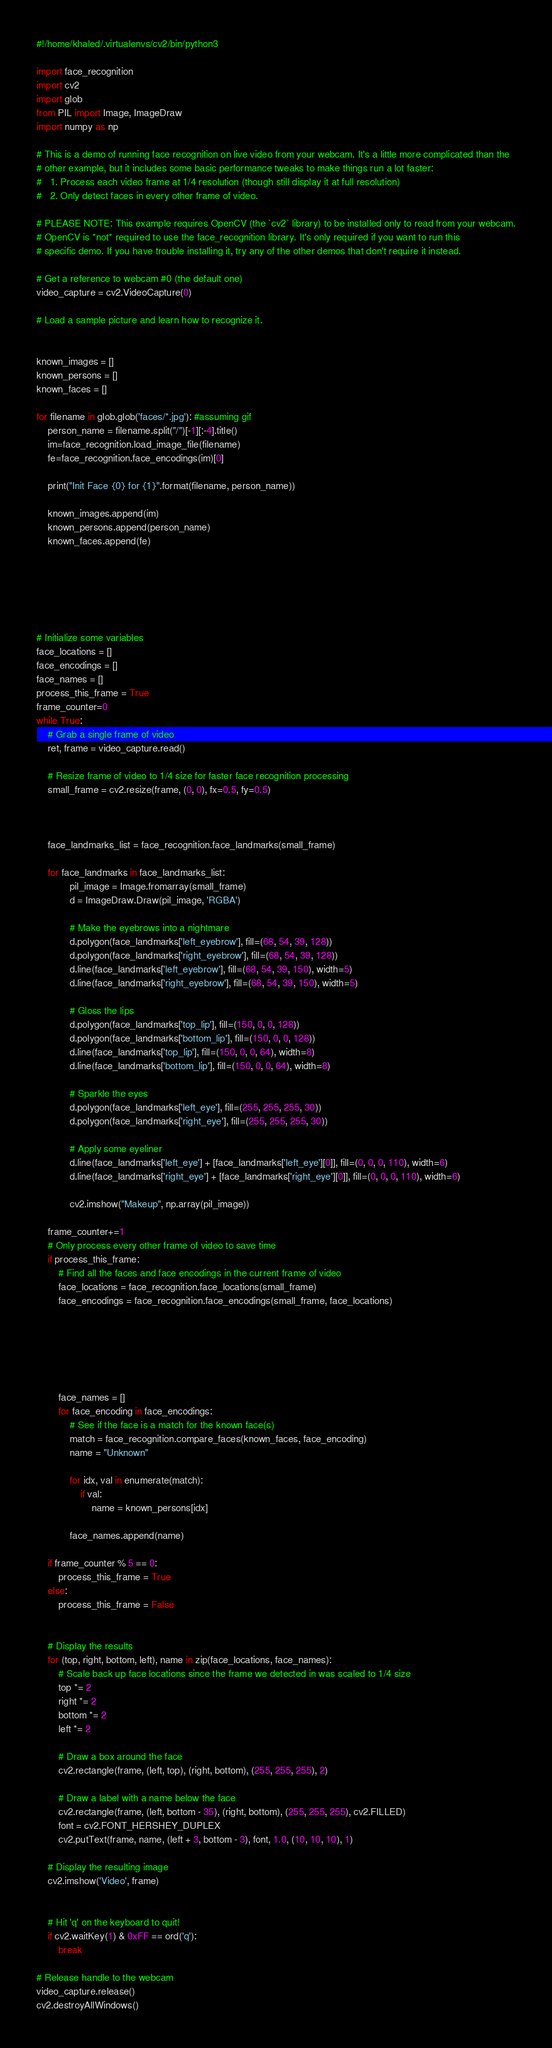<code> <loc_0><loc_0><loc_500><loc_500><_Python_>#!/home/khaled/.virtualenvs/cv2/bin/python3

import face_recognition
import cv2
import glob
from PIL import Image, ImageDraw
import numpy as np

# This is a demo of running face recognition on live video from your webcam. It's a little more complicated than the
# other example, but it includes some basic performance tweaks to make things run a lot faster:
#   1. Process each video frame at 1/4 resolution (though still display it at full resolution)
#   2. Only detect faces in every other frame of video.

# PLEASE NOTE: This example requires OpenCV (the `cv2` library) to be installed only to read from your webcam.
# OpenCV is *not* required to use the face_recognition library. It's only required if you want to run this
# specific demo. If you have trouble installing it, try any of the other demos that don't require it instead.

# Get a reference to webcam #0 (the default one)
video_capture = cv2.VideoCapture(0)

# Load a sample picture and learn how to recognize it.


known_images = []
known_persons = []
known_faces = []

for filename in glob.glob('faces/*.jpg'): #assuming gif
    person_name = filename.split("/")[-1][:-4].title()
    im=face_recognition.load_image_file(filename)
    fe=face_recognition.face_encodings(im)[0]

    print("Init Face {0} for {1}".format(filename, person_name))

    known_images.append(im)
    known_persons.append(person_name)
    known_faces.append(fe)






# Initialize some variables
face_locations = []
face_encodings = []
face_names = []
process_this_frame = True
frame_counter=0
while True:
    # Grab a single frame of video
    ret, frame = video_capture.read()

    # Resize frame of video to 1/4 size for faster face recognition processing
    small_frame = cv2.resize(frame, (0, 0), fx=0.5, fy=0.5)



    face_landmarks_list = face_recognition.face_landmarks(small_frame)
        
    for face_landmarks in face_landmarks_list:
            pil_image = Image.fromarray(small_frame)
            d = ImageDraw.Draw(pil_image, 'RGBA')

            # Make the eyebrows into a nightmare
            d.polygon(face_landmarks['left_eyebrow'], fill=(68, 54, 39, 128))
            d.polygon(face_landmarks['right_eyebrow'], fill=(68, 54, 39, 128))
            d.line(face_landmarks['left_eyebrow'], fill=(68, 54, 39, 150), width=5)
            d.line(face_landmarks['right_eyebrow'], fill=(68, 54, 39, 150), width=5)

            # Gloss the lips
            d.polygon(face_landmarks['top_lip'], fill=(150, 0, 0, 128))
            d.polygon(face_landmarks['bottom_lip'], fill=(150, 0, 0, 128))
            d.line(face_landmarks['top_lip'], fill=(150, 0, 0, 64), width=8)
            d.line(face_landmarks['bottom_lip'], fill=(150, 0, 0, 64), width=8)

            # Sparkle the eyes
            d.polygon(face_landmarks['left_eye'], fill=(255, 255, 255, 30))
            d.polygon(face_landmarks['right_eye'], fill=(255, 255, 255, 30))

            # Apply some eyeliner
            d.line(face_landmarks['left_eye'] + [face_landmarks['left_eye'][0]], fill=(0, 0, 0, 110), width=6)
            d.line(face_landmarks['right_eye'] + [face_landmarks['right_eye'][0]], fill=(0, 0, 0, 110), width=6)

            cv2.imshow("Makeup", np.array(pil_image))

    frame_counter+=1
    # Only process every other frame of video to save time
    if process_this_frame:
        # Find all the faces and face encodings in the current frame of video
        face_locations = face_recognition.face_locations(small_frame)
        face_encodings = face_recognition.face_encodings(small_frame, face_locations)

            




        face_names = []
        for face_encoding in face_encodings:
            # See if the face is a match for the known face(s)
            match = face_recognition.compare_faces(known_faces, face_encoding)
            name = "Unknown"

            for idx, val in enumerate(match):
                if val:
                    name = known_persons[idx]

            face_names.append(name)

    if frame_counter % 5 == 0: 
        process_this_frame = True
    else:
        process_this_frame = False


    # Display the results
    for (top, right, bottom, left), name in zip(face_locations, face_names):
        # Scale back up face locations since the frame we detected in was scaled to 1/4 size
        top *= 2
        right *= 2
        bottom *= 2
        left *= 2

        # Draw a box around the face
        cv2.rectangle(frame, (left, top), (right, bottom), (255, 255, 255), 2)

        # Draw a label with a name below the face
        cv2.rectangle(frame, (left, bottom - 35), (right, bottom), (255, 255, 255), cv2.FILLED)
        font = cv2.FONT_HERSHEY_DUPLEX
        cv2.putText(frame, name, (left + 3, bottom - 3), font, 1.0, (10, 10, 10), 1)

    # Display the resulting image
    cv2.imshow('Video', frame)
    

    # Hit 'q' on the keyboard to quit!
    if cv2.waitKey(1) & 0xFF == ord('q'):
        break

# Release handle to the webcam
video_capture.release()
cv2.destroyAllWindows()</code> 